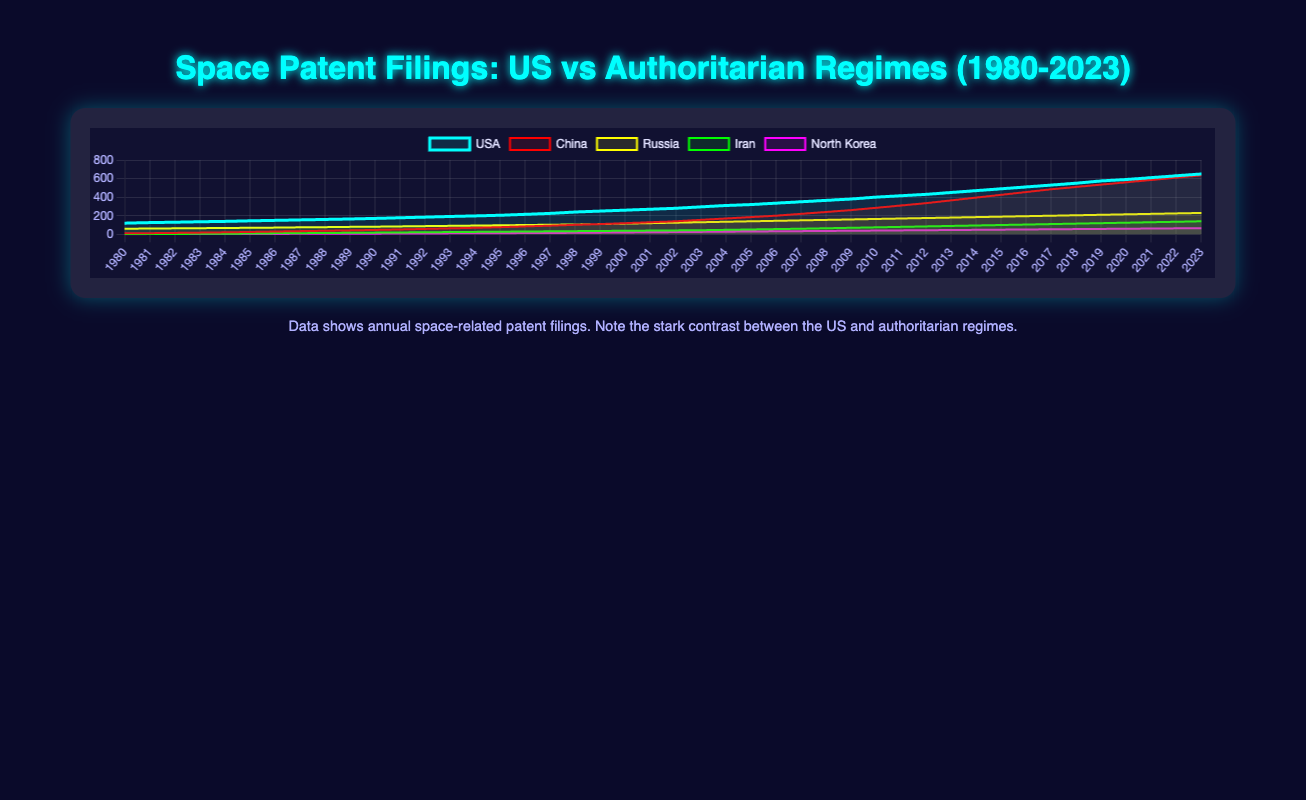Which country had the highest number of space-related patent filings in 2023? The figure shows five different datasets representing various countries. By looking at the lines for the year 2023, it is clear that the US has the highest number of filings as its value is the peak among all the lines.
Answer: USA By how much did China's space patents increase from 1980 to 2023? To determine the increase, subtract the number of filings in 1980 from the number in 2023. For China, there were 10 filings in 1980 and 635 in 2023. Therefore, the increase is 635 - 10 = 625.
Answer: 625 Which country showed the most consistent growth in space-related patent filings between 1980 and 2023? A consistent growth rate would be represented by a smooth and steady incline in the line plot. In this case, Russia's line appears to be the smoothest and most consistent, suggesting a steady increase each year.
Answer: Russia Which two countries' space patent filings were closest in 2000? By observing the lines at the year 2000 point, we can see that Russia and China have relatively close values at this year, with Russia at 115 and China at 120.
Answer: Russia and China What is the difference in the number of space-related patents filed in 2023 between the US and North Korea? To find the difference, subtract North Korea's filings from the US's filings in 2023. The US has 650 filings, and North Korea has 66 filings, so the difference is 650 - 66.
Answer: 584 Between which two consecutive years did Iran see the largest increase in space-related patents? To find the largest increase, inspect the gaps between each year for Iran. The greatest jump is between 2003 and 2004, increasing from 44 filings to 48, thus an increase of 4 patents.
Answer: 2003 and 2004 Which country had the least number of space-related patent filings in 1995? By checking the filings for all countries in 1995, it is evident that North Korea had the least filings, with only 12 patents filed.
Answer: North Korea What was the average annual number of space-related patent filings for the US from 1980 to 1990? To calculate the average, sum the yearly filings for the US between 1980 and 1990 and then divide by the number of years. The filings are: 120, 126, 130, 135, 139, 145, 150, 155, 160, and 165, which sum to 1425. Dividing by 11 gives an average of around 129.55.
Answer: 129.55 By how much did the space-related patent filings in the US increase from 2000 to 2010? Subtract the number of filings in 2000 from those in 2010 for the US. This is 400 (2010) - 260 (2000) = 140.
Answer: 140 